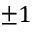<formula> <loc_0><loc_0><loc_500><loc_500>\pm 1</formula> 